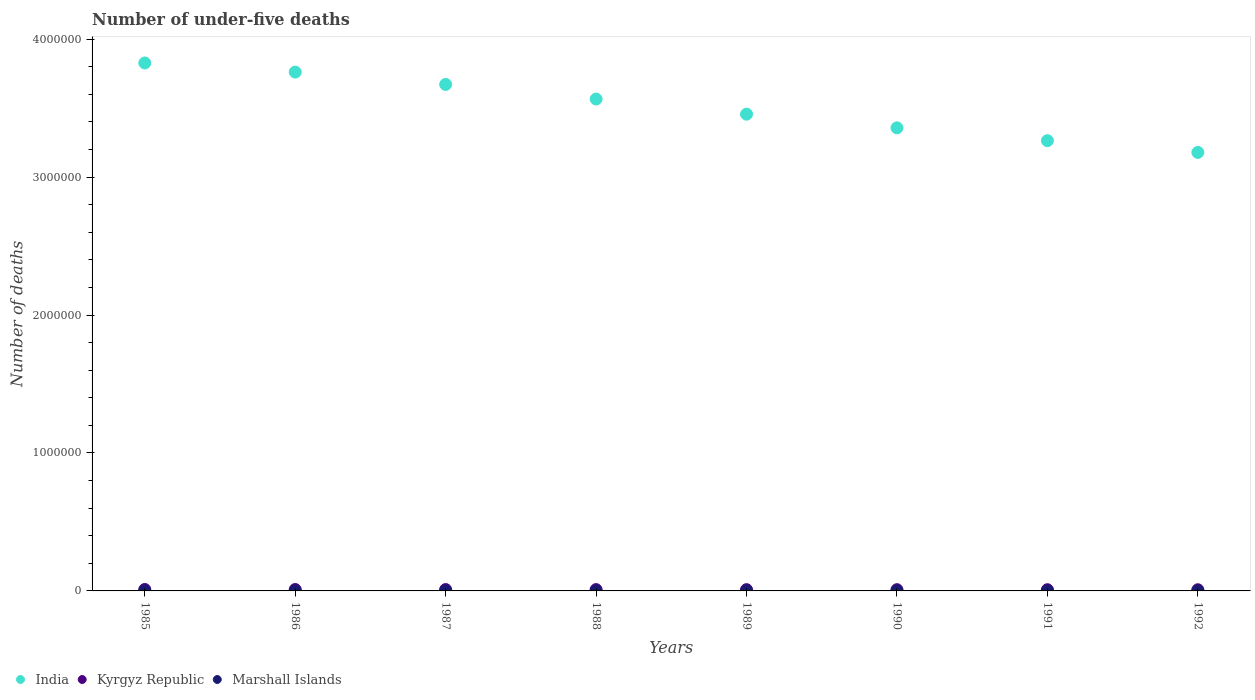How many different coloured dotlines are there?
Ensure brevity in your answer.  3. What is the number of under-five deaths in Kyrgyz Republic in 1991?
Provide a succinct answer. 8742. Across all years, what is the maximum number of under-five deaths in Marshall Islands?
Your response must be concise. 112. Across all years, what is the minimum number of under-five deaths in India?
Make the answer very short. 3.18e+06. In which year was the number of under-five deaths in Marshall Islands maximum?
Keep it short and to the point. 1986. What is the total number of under-five deaths in India in the graph?
Make the answer very short. 2.81e+07. What is the difference between the number of under-five deaths in Marshall Islands in 1985 and that in 1989?
Ensure brevity in your answer.  5. What is the difference between the number of under-five deaths in India in 1988 and the number of under-five deaths in Kyrgyz Republic in 1990?
Ensure brevity in your answer.  3.56e+06. What is the average number of under-five deaths in India per year?
Your answer should be very brief. 3.51e+06. In the year 1991, what is the difference between the number of under-five deaths in India and number of under-five deaths in Kyrgyz Republic?
Offer a terse response. 3.26e+06. In how many years, is the number of under-five deaths in India greater than 2800000?
Offer a very short reply. 8. What is the ratio of the number of under-five deaths in Marshall Islands in 1988 to that in 1992?
Make the answer very short. 1.17. What is the difference between the highest and the second highest number of under-five deaths in India?
Provide a short and direct response. 6.61e+04. What is the difference between the highest and the lowest number of under-five deaths in Marshall Islands?
Keep it short and to the point. 19. In how many years, is the number of under-five deaths in Kyrgyz Republic greater than the average number of under-five deaths in Kyrgyz Republic taken over all years?
Offer a terse response. 4. Is the sum of the number of under-five deaths in Marshall Islands in 1989 and 1990 greater than the maximum number of under-five deaths in India across all years?
Make the answer very short. No. Does the number of under-five deaths in India monotonically increase over the years?
Provide a succinct answer. No. Is the number of under-five deaths in India strictly greater than the number of under-five deaths in Kyrgyz Republic over the years?
Offer a terse response. Yes. How many years are there in the graph?
Provide a succinct answer. 8. What is the difference between two consecutive major ticks on the Y-axis?
Give a very brief answer. 1.00e+06. Does the graph contain any zero values?
Your response must be concise. No. Where does the legend appear in the graph?
Provide a short and direct response. Bottom left. How many legend labels are there?
Give a very brief answer. 3. What is the title of the graph?
Offer a terse response. Number of under-five deaths. Does "Swaziland" appear as one of the legend labels in the graph?
Your answer should be compact. No. What is the label or title of the Y-axis?
Offer a very short reply. Number of deaths. What is the Number of deaths in India in 1985?
Ensure brevity in your answer.  3.83e+06. What is the Number of deaths of Kyrgyz Republic in 1985?
Offer a very short reply. 1.03e+04. What is the Number of deaths of Marshall Islands in 1985?
Keep it short and to the point. 111. What is the Number of deaths in India in 1986?
Offer a very short reply. 3.76e+06. What is the Number of deaths of Kyrgyz Republic in 1986?
Give a very brief answer. 1.01e+04. What is the Number of deaths of Marshall Islands in 1986?
Provide a succinct answer. 112. What is the Number of deaths of India in 1987?
Offer a terse response. 3.67e+06. What is the Number of deaths of Kyrgyz Republic in 1987?
Offer a very short reply. 9800. What is the Number of deaths of Marshall Islands in 1987?
Offer a terse response. 111. What is the Number of deaths of India in 1988?
Make the answer very short. 3.57e+06. What is the Number of deaths in Kyrgyz Republic in 1988?
Provide a succinct answer. 9481. What is the Number of deaths in Marshall Islands in 1988?
Offer a very short reply. 109. What is the Number of deaths in India in 1989?
Provide a short and direct response. 3.46e+06. What is the Number of deaths of Kyrgyz Republic in 1989?
Keep it short and to the point. 9173. What is the Number of deaths of Marshall Islands in 1989?
Provide a succinct answer. 106. What is the Number of deaths in India in 1990?
Make the answer very short. 3.36e+06. What is the Number of deaths of Kyrgyz Republic in 1990?
Your answer should be compact. 8918. What is the Number of deaths of Marshall Islands in 1990?
Provide a succinct answer. 101. What is the Number of deaths in India in 1991?
Provide a short and direct response. 3.26e+06. What is the Number of deaths in Kyrgyz Republic in 1991?
Your response must be concise. 8742. What is the Number of deaths in Marshall Islands in 1991?
Your answer should be compact. 97. What is the Number of deaths of India in 1992?
Offer a very short reply. 3.18e+06. What is the Number of deaths in Kyrgyz Republic in 1992?
Keep it short and to the point. 8482. What is the Number of deaths of Marshall Islands in 1992?
Your response must be concise. 93. Across all years, what is the maximum Number of deaths of India?
Provide a short and direct response. 3.83e+06. Across all years, what is the maximum Number of deaths of Kyrgyz Republic?
Provide a short and direct response. 1.03e+04. Across all years, what is the maximum Number of deaths of Marshall Islands?
Give a very brief answer. 112. Across all years, what is the minimum Number of deaths of India?
Give a very brief answer. 3.18e+06. Across all years, what is the minimum Number of deaths in Kyrgyz Republic?
Your answer should be compact. 8482. Across all years, what is the minimum Number of deaths in Marshall Islands?
Provide a succinct answer. 93. What is the total Number of deaths in India in the graph?
Make the answer very short. 2.81e+07. What is the total Number of deaths in Kyrgyz Republic in the graph?
Make the answer very short. 7.50e+04. What is the total Number of deaths in Marshall Islands in the graph?
Offer a terse response. 840. What is the difference between the Number of deaths of India in 1985 and that in 1986?
Make the answer very short. 6.61e+04. What is the difference between the Number of deaths of Kyrgyz Republic in 1985 and that in 1986?
Offer a very short reply. 243. What is the difference between the Number of deaths of India in 1985 and that in 1987?
Provide a short and direct response. 1.56e+05. What is the difference between the Number of deaths of Kyrgyz Republic in 1985 and that in 1987?
Provide a short and direct response. 536. What is the difference between the Number of deaths in India in 1985 and that in 1988?
Your answer should be compact. 2.61e+05. What is the difference between the Number of deaths of Kyrgyz Republic in 1985 and that in 1988?
Make the answer very short. 855. What is the difference between the Number of deaths in India in 1985 and that in 1989?
Make the answer very short. 3.71e+05. What is the difference between the Number of deaths in Kyrgyz Republic in 1985 and that in 1989?
Provide a succinct answer. 1163. What is the difference between the Number of deaths of Marshall Islands in 1985 and that in 1989?
Provide a succinct answer. 5. What is the difference between the Number of deaths in India in 1985 and that in 1990?
Offer a terse response. 4.70e+05. What is the difference between the Number of deaths in Kyrgyz Republic in 1985 and that in 1990?
Your response must be concise. 1418. What is the difference between the Number of deaths in India in 1985 and that in 1991?
Make the answer very short. 5.63e+05. What is the difference between the Number of deaths of Kyrgyz Republic in 1985 and that in 1991?
Provide a succinct answer. 1594. What is the difference between the Number of deaths of Marshall Islands in 1985 and that in 1991?
Ensure brevity in your answer.  14. What is the difference between the Number of deaths of India in 1985 and that in 1992?
Your answer should be very brief. 6.48e+05. What is the difference between the Number of deaths of Kyrgyz Republic in 1985 and that in 1992?
Offer a very short reply. 1854. What is the difference between the Number of deaths of India in 1986 and that in 1987?
Make the answer very short. 8.95e+04. What is the difference between the Number of deaths of Kyrgyz Republic in 1986 and that in 1987?
Offer a very short reply. 293. What is the difference between the Number of deaths of India in 1986 and that in 1988?
Offer a very short reply. 1.95e+05. What is the difference between the Number of deaths of Kyrgyz Republic in 1986 and that in 1988?
Your response must be concise. 612. What is the difference between the Number of deaths in India in 1986 and that in 1989?
Your answer should be very brief. 3.05e+05. What is the difference between the Number of deaths of Kyrgyz Republic in 1986 and that in 1989?
Provide a succinct answer. 920. What is the difference between the Number of deaths of Marshall Islands in 1986 and that in 1989?
Make the answer very short. 6. What is the difference between the Number of deaths in India in 1986 and that in 1990?
Provide a succinct answer. 4.04e+05. What is the difference between the Number of deaths of Kyrgyz Republic in 1986 and that in 1990?
Keep it short and to the point. 1175. What is the difference between the Number of deaths of India in 1986 and that in 1991?
Give a very brief answer. 4.97e+05. What is the difference between the Number of deaths of Kyrgyz Republic in 1986 and that in 1991?
Keep it short and to the point. 1351. What is the difference between the Number of deaths of Marshall Islands in 1986 and that in 1991?
Provide a short and direct response. 15. What is the difference between the Number of deaths of India in 1986 and that in 1992?
Provide a succinct answer. 5.82e+05. What is the difference between the Number of deaths in Kyrgyz Republic in 1986 and that in 1992?
Offer a terse response. 1611. What is the difference between the Number of deaths of Marshall Islands in 1986 and that in 1992?
Offer a very short reply. 19. What is the difference between the Number of deaths in India in 1987 and that in 1988?
Offer a terse response. 1.06e+05. What is the difference between the Number of deaths of Kyrgyz Republic in 1987 and that in 1988?
Keep it short and to the point. 319. What is the difference between the Number of deaths of India in 1987 and that in 1989?
Keep it short and to the point. 2.16e+05. What is the difference between the Number of deaths in Kyrgyz Republic in 1987 and that in 1989?
Your answer should be compact. 627. What is the difference between the Number of deaths of Marshall Islands in 1987 and that in 1989?
Make the answer very short. 5. What is the difference between the Number of deaths of India in 1987 and that in 1990?
Ensure brevity in your answer.  3.15e+05. What is the difference between the Number of deaths of Kyrgyz Republic in 1987 and that in 1990?
Offer a very short reply. 882. What is the difference between the Number of deaths of India in 1987 and that in 1991?
Your answer should be compact. 4.08e+05. What is the difference between the Number of deaths of Kyrgyz Republic in 1987 and that in 1991?
Keep it short and to the point. 1058. What is the difference between the Number of deaths in Marshall Islands in 1987 and that in 1991?
Keep it short and to the point. 14. What is the difference between the Number of deaths of India in 1987 and that in 1992?
Your answer should be compact. 4.93e+05. What is the difference between the Number of deaths in Kyrgyz Republic in 1987 and that in 1992?
Provide a short and direct response. 1318. What is the difference between the Number of deaths in India in 1988 and that in 1989?
Give a very brief answer. 1.10e+05. What is the difference between the Number of deaths in Kyrgyz Republic in 1988 and that in 1989?
Offer a very short reply. 308. What is the difference between the Number of deaths of Marshall Islands in 1988 and that in 1989?
Provide a short and direct response. 3. What is the difference between the Number of deaths in India in 1988 and that in 1990?
Offer a terse response. 2.09e+05. What is the difference between the Number of deaths of Kyrgyz Republic in 1988 and that in 1990?
Offer a very short reply. 563. What is the difference between the Number of deaths of India in 1988 and that in 1991?
Give a very brief answer. 3.02e+05. What is the difference between the Number of deaths of Kyrgyz Republic in 1988 and that in 1991?
Provide a succinct answer. 739. What is the difference between the Number of deaths in India in 1988 and that in 1992?
Give a very brief answer. 3.87e+05. What is the difference between the Number of deaths of Kyrgyz Republic in 1988 and that in 1992?
Offer a very short reply. 999. What is the difference between the Number of deaths of India in 1989 and that in 1990?
Offer a very short reply. 9.92e+04. What is the difference between the Number of deaths in Kyrgyz Republic in 1989 and that in 1990?
Provide a succinct answer. 255. What is the difference between the Number of deaths of Marshall Islands in 1989 and that in 1990?
Offer a very short reply. 5. What is the difference between the Number of deaths in India in 1989 and that in 1991?
Your answer should be very brief. 1.92e+05. What is the difference between the Number of deaths in Kyrgyz Republic in 1989 and that in 1991?
Your answer should be compact. 431. What is the difference between the Number of deaths of India in 1989 and that in 1992?
Provide a succinct answer. 2.77e+05. What is the difference between the Number of deaths of Kyrgyz Republic in 1989 and that in 1992?
Provide a short and direct response. 691. What is the difference between the Number of deaths in India in 1990 and that in 1991?
Your answer should be very brief. 9.31e+04. What is the difference between the Number of deaths of Kyrgyz Republic in 1990 and that in 1991?
Make the answer very short. 176. What is the difference between the Number of deaths of Marshall Islands in 1990 and that in 1991?
Your answer should be very brief. 4. What is the difference between the Number of deaths in India in 1990 and that in 1992?
Make the answer very short. 1.78e+05. What is the difference between the Number of deaths in Kyrgyz Republic in 1990 and that in 1992?
Your answer should be very brief. 436. What is the difference between the Number of deaths in India in 1991 and that in 1992?
Provide a short and direct response. 8.50e+04. What is the difference between the Number of deaths in Kyrgyz Republic in 1991 and that in 1992?
Your answer should be very brief. 260. What is the difference between the Number of deaths of Marshall Islands in 1991 and that in 1992?
Ensure brevity in your answer.  4. What is the difference between the Number of deaths in India in 1985 and the Number of deaths in Kyrgyz Republic in 1986?
Ensure brevity in your answer.  3.82e+06. What is the difference between the Number of deaths in India in 1985 and the Number of deaths in Marshall Islands in 1986?
Give a very brief answer. 3.83e+06. What is the difference between the Number of deaths in Kyrgyz Republic in 1985 and the Number of deaths in Marshall Islands in 1986?
Provide a succinct answer. 1.02e+04. What is the difference between the Number of deaths in India in 1985 and the Number of deaths in Kyrgyz Republic in 1987?
Keep it short and to the point. 3.82e+06. What is the difference between the Number of deaths in India in 1985 and the Number of deaths in Marshall Islands in 1987?
Give a very brief answer. 3.83e+06. What is the difference between the Number of deaths in Kyrgyz Republic in 1985 and the Number of deaths in Marshall Islands in 1987?
Your response must be concise. 1.02e+04. What is the difference between the Number of deaths in India in 1985 and the Number of deaths in Kyrgyz Republic in 1988?
Your answer should be very brief. 3.82e+06. What is the difference between the Number of deaths of India in 1985 and the Number of deaths of Marshall Islands in 1988?
Make the answer very short. 3.83e+06. What is the difference between the Number of deaths of Kyrgyz Republic in 1985 and the Number of deaths of Marshall Islands in 1988?
Offer a terse response. 1.02e+04. What is the difference between the Number of deaths of India in 1985 and the Number of deaths of Kyrgyz Republic in 1989?
Offer a terse response. 3.82e+06. What is the difference between the Number of deaths of India in 1985 and the Number of deaths of Marshall Islands in 1989?
Your response must be concise. 3.83e+06. What is the difference between the Number of deaths in Kyrgyz Republic in 1985 and the Number of deaths in Marshall Islands in 1989?
Your answer should be very brief. 1.02e+04. What is the difference between the Number of deaths of India in 1985 and the Number of deaths of Kyrgyz Republic in 1990?
Provide a succinct answer. 3.82e+06. What is the difference between the Number of deaths of India in 1985 and the Number of deaths of Marshall Islands in 1990?
Make the answer very short. 3.83e+06. What is the difference between the Number of deaths of Kyrgyz Republic in 1985 and the Number of deaths of Marshall Islands in 1990?
Give a very brief answer. 1.02e+04. What is the difference between the Number of deaths of India in 1985 and the Number of deaths of Kyrgyz Republic in 1991?
Your answer should be very brief. 3.82e+06. What is the difference between the Number of deaths in India in 1985 and the Number of deaths in Marshall Islands in 1991?
Offer a very short reply. 3.83e+06. What is the difference between the Number of deaths of Kyrgyz Republic in 1985 and the Number of deaths of Marshall Islands in 1991?
Your answer should be very brief. 1.02e+04. What is the difference between the Number of deaths of India in 1985 and the Number of deaths of Kyrgyz Republic in 1992?
Give a very brief answer. 3.82e+06. What is the difference between the Number of deaths of India in 1985 and the Number of deaths of Marshall Islands in 1992?
Provide a succinct answer. 3.83e+06. What is the difference between the Number of deaths in Kyrgyz Republic in 1985 and the Number of deaths in Marshall Islands in 1992?
Give a very brief answer. 1.02e+04. What is the difference between the Number of deaths in India in 1986 and the Number of deaths in Kyrgyz Republic in 1987?
Provide a short and direct response. 3.75e+06. What is the difference between the Number of deaths in India in 1986 and the Number of deaths in Marshall Islands in 1987?
Give a very brief answer. 3.76e+06. What is the difference between the Number of deaths in Kyrgyz Republic in 1986 and the Number of deaths in Marshall Islands in 1987?
Ensure brevity in your answer.  9982. What is the difference between the Number of deaths in India in 1986 and the Number of deaths in Kyrgyz Republic in 1988?
Your answer should be compact. 3.75e+06. What is the difference between the Number of deaths in India in 1986 and the Number of deaths in Marshall Islands in 1988?
Your answer should be compact. 3.76e+06. What is the difference between the Number of deaths of Kyrgyz Republic in 1986 and the Number of deaths of Marshall Islands in 1988?
Provide a short and direct response. 9984. What is the difference between the Number of deaths in India in 1986 and the Number of deaths in Kyrgyz Republic in 1989?
Keep it short and to the point. 3.75e+06. What is the difference between the Number of deaths in India in 1986 and the Number of deaths in Marshall Islands in 1989?
Your response must be concise. 3.76e+06. What is the difference between the Number of deaths of Kyrgyz Republic in 1986 and the Number of deaths of Marshall Islands in 1989?
Provide a succinct answer. 9987. What is the difference between the Number of deaths in India in 1986 and the Number of deaths in Kyrgyz Republic in 1990?
Offer a very short reply. 3.75e+06. What is the difference between the Number of deaths of India in 1986 and the Number of deaths of Marshall Islands in 1990?
Provide a succinct answer. 3.76e+06. What is the difference between the Number of deaths of Kyrgyz Republic in 1986 and the Number of deaths of Marshall Islands in 1990?
Offer a terse response. 9992. What is the difference between the Number of deaths in India in 1986 and the Number of deaths in Kyrgyz Republic in 1991?
Your response must be concise. 3.75e+06. What is the difference between the Number of deaths in India in 1986 and the Number of deaths in Marshall Islands in 1991?
Make the answer very short. 3.76e+06. What is the difference between the Number of deaths of Kyrgyz Republic in 1986 and the Number of deaths of Marshall Islands in 1991?
Provide a short and direct response. 9996. What is the difference between the Number of deaths in India in 1986 and the Number of deaths in Kyrgyz Republic in 1992?
Offer a very short reply. 3.75e+06. What is the difference between the Number of deaths in India in 1986 and the Number of deaths in Marshall Islands in 1992?
Provide a short and direct response. 3.76e+06. What is the difference between the Number of deaths in Kyrgyz Republic in 1986 and the Number of deaths in Marshall Islands in 1992?
Your answer should be compact. 10000. What is the difference between the Number of deaths of India in 1987 and the Number of deaths of Kyrgyz Republic in 1988?
Offer a terse response. 3.66e+06. What is the difference between the Number of deaths of India in 1987 and the Number of deaths of Marshall Islands in 1988?
Your response must be concise. 3.67e+06. What is the difference between the Number of deaths of Kyrgyz Republic in 1987 and the Number of deaths of Marshall Islands in 1988?
Keep it short and to the point. 9691. What is the difference between the Number of deaths of India in 1987 and the Number of deaths of Kyrgyz Republic in 1989?
Your response must be concise. 3.66e+06. What is the difference between the Number of deaths in India in 1987 and the Number of deaths in Marshall Islands in 1989?
Offer a terse response. 3.67e+06. What is the difference between the Number of deaths of Kyrgyz Republic in 1987 and the Number of deaths of Marshall Islands in 1989?
Offer a terse response. 9694. What is the difference between the Number of deaths of India in 1987 and the Number of deaths of Kyrgyz Republic in 1990?
Provide a succinct answer. 3.66e+06. What is the difference between the Number of deaths in India in 1987 and the Number of deaths in Marshall Islands in 1990?
Provide a succinct answer. 3.67e+06. What is the difference between the Number of deaths in Kyrgyz Republic in 1987 and the Number of deaths in Marshall Islands in 1990?
Offer a terse response. 9699. What is the difference between the Number of deaths in India in 1987 and the Number of deaths in Kyrgyz Republic in 1991?
Give a very brief answer. 3.66e+06. What is the difference between the Number of deaths in India in 1987 and the Number of deaths in Marshall Islands in 1991?
Offer a terse response. 3.67e+06. What is the difference between the Number of deaths of Kyrgyz Republic in 1987 and the Number of deaths of Marshall Islands in 1991?
Give a very brief answer. 9703. What is the difference between the Number of deaths in India in 1987 and the Number of deaths in Kyrgyz Republic in 1992?
Provide a short and direct response. 3.66e+06. What is the difference between the Number of deaths of India in 1987 and the Number of deaths of Marshall Islands in 1992?
Make the answer very short. 3.67e+06. What is the difference between the Number of deaths of Kyrgyz Republic in 1987 and the Number of deaths of Marshall Islands in 1992?
Provide a succinct answer. 9707. What is the difference between the Number of deaths in India in 1988 and the Number of deaths in Kyrgyz Republic in 1989?
Give a very brief answer. 3.56e+06. What is the difference between the Number of deaths in India in 1988 and the Number of deaths in Marshall Islands in 1989?
Provide a short and direct response. 3.57e+06. What is the difference between the Number of deaths of Kyrgyz Republic in 1988 and the Number of deaths of Marshall Islands in 1989?
Your answer should be compact. 9375. What is the difference between the Number of deaths of India in 1988 and the Number of deaths of Kyrgyz Republic in 1990?
Provide a succinct answer. 3.56e+06. What is the difference between the Number of deaths in India in 1988 and the Number of deaths in Marshall Islands in 1990?
Offer a very short reply. 3.57e+06. What is the difference between the Number of deaths of Kyrgyz Republic in 1988 and the Number of deaths of Marshall Islands in 1990?
Keep it short and to the point. 9380. What is the difference between the Number of deaths in India in 1988 and the Number of deaths in Kyrgyz Republic in 1991?
Offer a terse response. 3.56e+06. What is the difference between the Number of deaths in India in 1988 and the Number of deaths in Marshall Islands in 1991?
Keep it short and to the point. 3.57e+06. What is the difference between the Number of deaths in Kyrgyz Republic in 1988 and the Number of deaths in Marshall Islands in 1991?
Your answer should be compact. 9384. What is the difference between the Number of deaths of India in 1988 and the Number of deaths of Kyrgyz Republic in 1992?
Give a very brief answer. 3.56e+06. What is the difference between the Number of deaths in India in 1988 and the Number of deaths in Marshall Islands in 1992?
Make the answer very short. 3.57e+06. What is the difference between the Number of deaths of Kyrgyz Republic in 1988 and the Number of deaths of Marshall Islands in 1992?
Your answer should be very brief. 9388. What is the difference between the Number of deaths of India in 1989 and the Number of deaths of Kyrgyz Republic in 1990?
Offer a terse response. 3.45e+06. What is the difference between the Number of deaths in India in 1989 and the Number of deaths in Marshall Islands in 1990?
Keep it short and to the point. 3.46e+06. What is the difference between the Number of deaths in Kyrgyz Republic in 1989 and the Number of deaths in Marshall Islands in 1990?
Keep it short and to the point. 9072. What is the difference between the Number of deaths of India in 1989 and the Number of deaths of Kyrgyz Republic in 1991?
Your answer should be compact. 3.45e+06. What is the difference between the Number of deaths of India in 1989 and the Number of deaths of Marshall Islands in 1991?
Provide a succinct answer. 3.46e+06. What is the difference between the Number of deaths in Kyrgyz Republic in 1989 and the Number of deaths in Marshall Islands in 1991?
Give a very brief answer. 9076. What is the difference between the Number of deaths of India in 1989 and the Number of deaths of Kyrgyz Republic in 1992?
Make the answer very short. 3.45e+06. What is the difference between the Number of deaths of India in 1989 and the Number of deaths of Marshall Islands in 1992?
Keep it short and to the point. 3.46e+06. What is the difference between the Number of deaths in Kyrgyz Republic in 1989 and the Number of deaths in Marshall Islands in 1992?
Keep it short and to the point. 9080. What is the difference between the Number of deaths of India in 1990 and the Number of deaths of Kyrgyz Republic in 1991?
Give a very brief answer. 3.35e+06. What is the difference between the Number of deaths in India in 1990 and the Number of deaths in Marshall Islands in 1991?
Offer a terse response. 3.36e+06. What is the difference between the Number of deaths of Kyrgyz Republic in 1990 and the Number of deaths of Marshall Islands in 1991?
Make the answer very short. 8821. What is the difference between the Number of deaths in India in 1990 and the Number of deaths in Kyrgyz Republic in 1992?
Give a very brief answer. 3.35e+06. What is the difference between the Number of deaths of India in 1990 and the Number of deaths of Marshall Islands in 1992?
Ensure brevity in your answer.  3.36e+06. What is the difference between the Number of deaths of Kyrgyz Republic in 1990 and the Number of deaths of Marshall Islands in 1992?
Your answer should be very brief. 8825. What is the difference between the Number of deaths in India in 1991 and the Number of deaths in Kyrgyz Republic in 1992?
Offer a terse response. 3.26e+06. What is the difference between the Number of deaths of India in 1991 and the Number of deaths of Marshall Islands in 1992?
Your response must be concise. 3.26e+06. What is the difference between the Number of deaths in Kyrgyz Republic in 1991 and the Number of deaths in Marshall Islands in 1992?
Give a very brief answer. 8649. What is the average Number of deaths of India per year?
Offer a very short reply. 3.51e+06. What is the average Number of deaths of Kyrgyz Republic per year?
Make the answer very short. 9378.12. What is the average Number of deaths in Marshall Islands per year?
Your answer should be compact. 105. In the year 1985, what is the difference between the Number of deaths in India and Number of deaths in Kyrgyz Republic?
Offer a very short reply. 3.82e+06. In the year 1985, what is the difference between the Number of deaths in India and Number of deaths in Marshall Islands?
Offer a very short reply. 3.83e+06. In the year 1985, what is the difference between the Number of deaths in Kyrgyz Republic and Number of deaths in Marshall Islands?
Provide a succinct answer. 1.02e+04. In the year 1986, what is the difference between the Number of deaths of India and Number of deaths of Kyrgyz Republic?
Your answer should be very brief. 3.75e+06. In the year 1986, what is the difference between the Number of deaths in India and Number of deaths in Marshall Islands?
Your response must be concise. 3.76e+06. In the year 1986, what is the difference between the Number of deaths in Kyrgyz Republic and Number of deaths in Marshall Islands?
Provide a short and direct response. 9981. In the year 1987, what is the difference between the Number of deaths in India and Number of deaths in Kyrgyz Republic?
Make the answer very short. 3.66e+06. In the year 1987, what is the difference between the Number of deaths of India and Number of deaths of Marshall Islands?
Provide a short and direct response. 3.67e+06. In the year 1987, what is the difference between the Number of deaths of Kyrgyz Republic and Number of deaths of Marshall Islands?
Make the answer very short. 9689. In the year 1988, what is the difference between the Number of deaths in India and Number of deaths in Kyrgyz Republic?
Provide a succinct answer. 3.56e+06. In the year 1988, what is the difference between the Number of deaths of India and Number of deaths of Marshall Islands?
Keep it short and to the point. 3.57e+06. In the year 1988, what is the difference between the Number of deaths of Kyrgyz Republic and Number of deaths of Marshall Islands?
Your answer should be compact. 9372. In the year 1989, what is the difference between the Number of deaths of India and Number of deaths of Kyrgyz Republic?
Provide a short and direct response. 3.45e+06. In the year 1989, what is the difference between the Number of deaths of India and Number of deaths of Marshall Islands?
Your answer should be compact. 3.46e+06. In the year 1989, what is the difference between the Number of deaths in Kyrgyz Republic and Number of deaths in Marshall Islands?
Offer a terse response. 9067. In the year 1990, what is the difference between the Number of deaths of India and Number of deaths of Kyrgyz Republic?
Ensure brevity in your answer.  3.35e+06. In the year 1990, what is the difference between the Number of deaths of India and Number of deaths of Marshall Islands?
Keep it short and to the point. 3.36e+06. In the year 1990, what is the difference between the Number of deaths of Kyrgyz Republic and Number of deaths of Marshall Islands?
Give a very brief answer. 8817. In the year 1991, what is the difference between the Number of deaths in India and Number of deaths in Kyrgyz Republic?
Your answer should be compact. 3.26e+06. In the year 1991, what is the difference between the Number of deaths in India and Number of deaths in Marshall Islands?
Provide a succinct answer. 3.26e+06. In the year 1991, what is the difference between the Number of deaths of Kyrgyz Republic and Number of deaths of Marshall Islands?
Keep it short and to the point. 8645. In the year 1992, what is the difference between the Number of deaths in India and Number of deaths in Kyrgyz Republic?
Give a very brief answer. 3.17e+06. In the year 1992, what is the difference between the Number of deaths of India and Number of deaths of Marshall Islands?
Make the answer very short. 3.18e+06. In the year 1992, what is the difference between the Number of deaths in Kyrgyz Republic and Number of deaths in Marshall Islands?
Give a very brief answer. 8389. What is the ratio of the Number of deaths in India in 1985 to that in 1986?
Provide a succinct answer. 1.02. What is the ratio of the Number of deaths of Kyrgyz Republic in 1985 to that in 1986?
Give a very brief answer. 1.02. What is the ratio of the Number of deaths of Marshall Islands in 1985 to that in 1986?
Your response must be concise. 0.99. What is the ratio of the Number of deaths of India in 1985 to that in 1987?
Provide a succinct answer. 1.04. What is the ratio of the Number of deaths in Kyrgyz Republic in 1985 to that in 1987?
Offer a very short reply. 1.05. What is the ratio of the Number of deaths of India in 1985 to that in 1988?
Your answer should be compact. 1.07. What is the ratio of the Number of deaths in Kyrgyz Republic in 1985 to that in 1988?
Offer a terse response. 1.09. What is the ratio of the Number of deaths in Marshall Islands in 1985 to that in 1988?
Keep it short and to the point. 1.02. What is the ratio of the Number of deaths in India in 1985 to that in 1989?
Offer a very short reply. 1.11. What is the ratio of the Number of deaths in Kyrgyz Republic in 1985 to that in 1989?
Provide a short and direct response. 1.13. What is the ratio of the Number of deaths of Marshall Islands in 1985 to that in 1989?
Offer a terse response. 1.05. What is the ratio of the Number of deaths of India in 1985 to that in 1990?
Give a very brief answer. 1.14. What is the ratio of the Number of deaths of Kyrgyz Republic in 1985 to that in 1990?
Make the answer very short. 1.16. What is the ratio of the Number of deaths of Marshall Islands in 1985 to that in 1990?
Keep it short and to the point. 1.1. What is the ratio of the Number of deaths in India in 1985 to that in 1991?
Keep it short and to the point. 1.17. What is the ratio of the Number of deaths in Kyrgyz Republic in 1985 to that in 1991?
Make the answer very short. 1.18. What is the ratio of the Number of deaths in Marshall Islands in 1985 to that in 1991?
Make the answer very short. 1.14. What is the ratio of the Number of deaths of India in 1985 to that in 1992?
Your answer should be compact. 1.2. What is the ratio of the Number of deaths of Kyrgyz Republic in 1985 to that in 1992?
Your answer should be very brief. 1.22. What is the ratio of the Number of deaths of Marshall Islands in 1985 to that in 1992?
Keep it short and to the point. 1.19. What is the ratio of the Number of deaths in India in 1986 to that in 1987?
Your response must be concise. 1.02. What is the ratio of the Number of deaths of Kyrgyz Republic in 1986 to that in 1987?
Offer a very short reply. 1.03. What is the ratio of the Number of deaths of India in 1986 to that in 1988?
Make the answer very short. 1.05. What is the ratio of the Number of deaths of Kyrgyz Republic in 1986 to that in 1988?
Give a very brief answer. 1.06. What is the ratio of the Number of deaths of Marshall Islands in 1986 to that in 1988?
Offer a very short reply. 1.03. What is the ratio of the Number of deaths of India in 1986 to that in 1989?
Provide a succinct answer. 1.09. What is the ratio of the Number of deaths of Kyrgyz Republic in 1986 to that in 1989?
Provide a short and direct response. 1.1. What is the ratio of the Number of deaths in Marshall Islands in 1986 to that in 1989?
Provide a succinct answer. 1.06. What is the ratio of the Number of deaths of India in 1986 to that in 1990?
Your answer should be very brief. 1.12. What is the ratio of the Number of deaths in Kyrgyz Republic in 1986 to that in 1990?
Your answer should be compact. 1.13. What is the ratio of the Number of deaths in Marshall Islands in 1986 to that in 1990?
Offer a very short reply. 1.11. What is the ratio of the Number of deaths of India in 1986 to that in 1991?
Offer a very short reply. 1.15. What is the ratio of the Number of deaths of Kyrgyz Republic in 1986 to that in 1991?
Keep it short and to the point. 1.15. What is the ratio of the Number of deaths in Marshall Islands in 1986 to that in 1991?
Provide a short and direct response. 1.15. What is the ratio of the Number of deaths of India in 1986 to that in 1992?
Provide a short and direct response. 1.18. What is the ratio of the Number of deaths of Kyrgyz Republic in 1986 to that in 1992?
Ensure brevity in your answer.  1.19. What is the ratio of the Number of deaths in Marshall Islands in 1986 to that in 1992?
Your answer should be very brief. 1.2. What is the ratio of the Number of deaths in India in 1987 to that in 1988?
Your answer should be compact. 1.03. What is the ratio of the Number of deaths of Kyrgyz Republic in 1987 to that in 1988?
Your answer should be compact. 1.03. What is the ratio of the Number of deaths in Marshall Islands in 1987 to that in 1988?
Provide a short and direct response. 1.02. What is the ratio of the Number of deaths of India in 1987 to that in 1989?
Give a very brief answer. 1.06. What is the ratio of the Number of deaths in Kyrgyz Republic in 1987 to that in 1989?
Ensure brevity in your answer.  1.07. What is the ratio of the Number of deaths of Marshall Islands in 1987 to that in 1989?
Ensure brevity in your answer.  1.05. What is the ratio of the Number of deaths of India in 1987 to that in 1990?
Make the answer very short. 1.09. What is the ratio of the Number of deaths of Kyrgyz Republic in 1987 to that in 1990?
Provide a succinct answer. 1.1. What is the ratio of the Number of deaths in Marshall Islands in 1987 to that in 1990?
Your answer should be compact. 1.1. What is the ratio of the Number of deaths in India in 1987 to that in 1991?
Offer a very short reply. 1.12. What is the ratio of the Number of deaths in Kyrgyz Republic in 1987 to that in 1991?
Your answer should be very brief. 1.12. What is the ratio of the Number of deaths of Marshall Islands in 1987 to that in 1991?
Make the answer very short. 1.14. What is the ratio of the Number of deaths in India in 1987 to that in 1992?
Make the answer very short. 1.16. What is the ratio of the Number of deaths of Kyrgyz Republic in 1987 to that in 1992?
Provide a succinct answer. 1.16. What is the ratio of the Number of deaths in Marshall Islands in 1987 to that in 1992?
Provide a short and direct response. 1.19. What is the ratio of the Number of deaths of India in 1988 to that in 1989?
Your response must be concise. 1.03. What is the ratio of the Number of deaths in Kyrgyz Republic in 1988 to that in 1989?
Make the answer very short. 1.03. What is the ratio of the Number of deaths in Marshall Islands in 1988 to that in 1989?
Provide a short and direct response. 1.03. What is the ratio of the Number of deaths in India in 1988 to that in 1990?
Offer a terse response. 1.06. What is the ratio of the Number of deaths in Kyrgyz Republic in 1988 to that in 1990?
Offer a very short reply. 1.06. What is the ratio of the Number of deaths in Marshall Islands in 1988 to that in 1990?
Provide a succinct answer. 1.08. What is the ratio of the Number of deaths of India in 1988 to that in 1991?
Make the answer very short. 1.09. What is the ratio of the Number of deaths of Kyrgyz Republic in 1988 to that in 1991?
Your answer should be very brief. 1.08. What is the ratio of the Number of deaths of Marshall Islands in 1988 to that in 1991?
Give a very brief answer. 1.12. What is the ratio of the Number of deaths in India in 1988 to that in 1992?
Offer a terse response. 1.12. What is the ratio of the Number of deaths of Kyrgyz Republic in 1988 to that in 1992?
Provide a short and direct response. 1.12. What is the ratio of the Number of deaths of Marshall Islands in 1988 to that in 1992?
Provide a succinct answer. 1.17. What is the ratio of the Number of deaths in India in 1989 to that in 1990?
Give a very brief answer. 1.03. What is the ratio of the Number of deaths in Kyrgyz Republic in 1989 to that in 1990?
Provide a succinct answer. 1.03. What is the ratio of the Number of deaths of Marshall Islands in 1989 to that in 1990?
Offer a terse response. 1.05. What is the ratio of the Number of deaths of India in 1989 to that in 1991?
Offer a very short reply. 1.06. What is the ratio of the Number of deaths in Kyrgyz Republic in 1989 to that in 1991?
Give a very brief answer. 1.05. What is the ratio of the Number of deaths in Marshall Islands in 1989 to that in 1991?
Offer a very short reply. 1.09. What is the ratio of the Number of deaths in India in 1989 to that in 1992?
Your answer should be very brief. 1.09. What is the ratio of the Number of deaths in Kyrgyz Republic in 1989 to that in 1992?
Give a very brief answer. 1.08. What is the ratio of the Number of deaths of Marshall Islands in 1989 to that in 1992?
Ensure brevity in your answer.  1.14. What is the ratio of the Number of deaths in India in 1990 to that in 1991?
Make the answer very short. 1.03. What is the ratio of the Number of deaths in Kyrgyz Republic in 1990 to that in 1991?
Offer a very short reply. 1.02. What is the ratio of the Number of deaths of Marshall Islands in 1990 to that in 1991?
Offer a terse response. 1.04. What is the ratio of the Number of deaths in India in 1990 to that in 1992?
Your response must be concise. 1.06. What is the ratio of the Number of deaths in Kyrgyz Republic in 1990 to that in 1992?
Make the answer very short. 1.05. What is the ratio of the Number of deaths of Marshall Islands in 1990 to that in 1992?
Make the answer very short. 1.09. What is the ratio of the Number of deaths in India in 1991 to that in 1992?
Keep it short and to the point. 1.03. What is the ratio of the Number of deaths of Kyrgyz Republic in 1991 to that in 1992?
Your answer should be very brief. 1.03. What is the ratio of the Number of deaths of Marshall Islands in 1991 to that in 1992?
Your response must be concise. 1.04. What is the difference between the highest and the second highest Number of deaths of India?
Your response must be concise. 6.61e+04. What is the difference between the highest and the second highest Number of deaths of Kyrgyz Republic?
Offer a very short reply. 243. What is the difference between the highest and the lowest Number of deaths of India?
Ensure brevity in your answer.  6.48e+05. What is the difference between the highest and the lowest Number of deaths of Kyrgyz Republic?
Your answer should be very brief. 1854. What is the difference between the highest and the lowest Number of deaths of Marshall Islands?
Your answer should be compact. 19. 